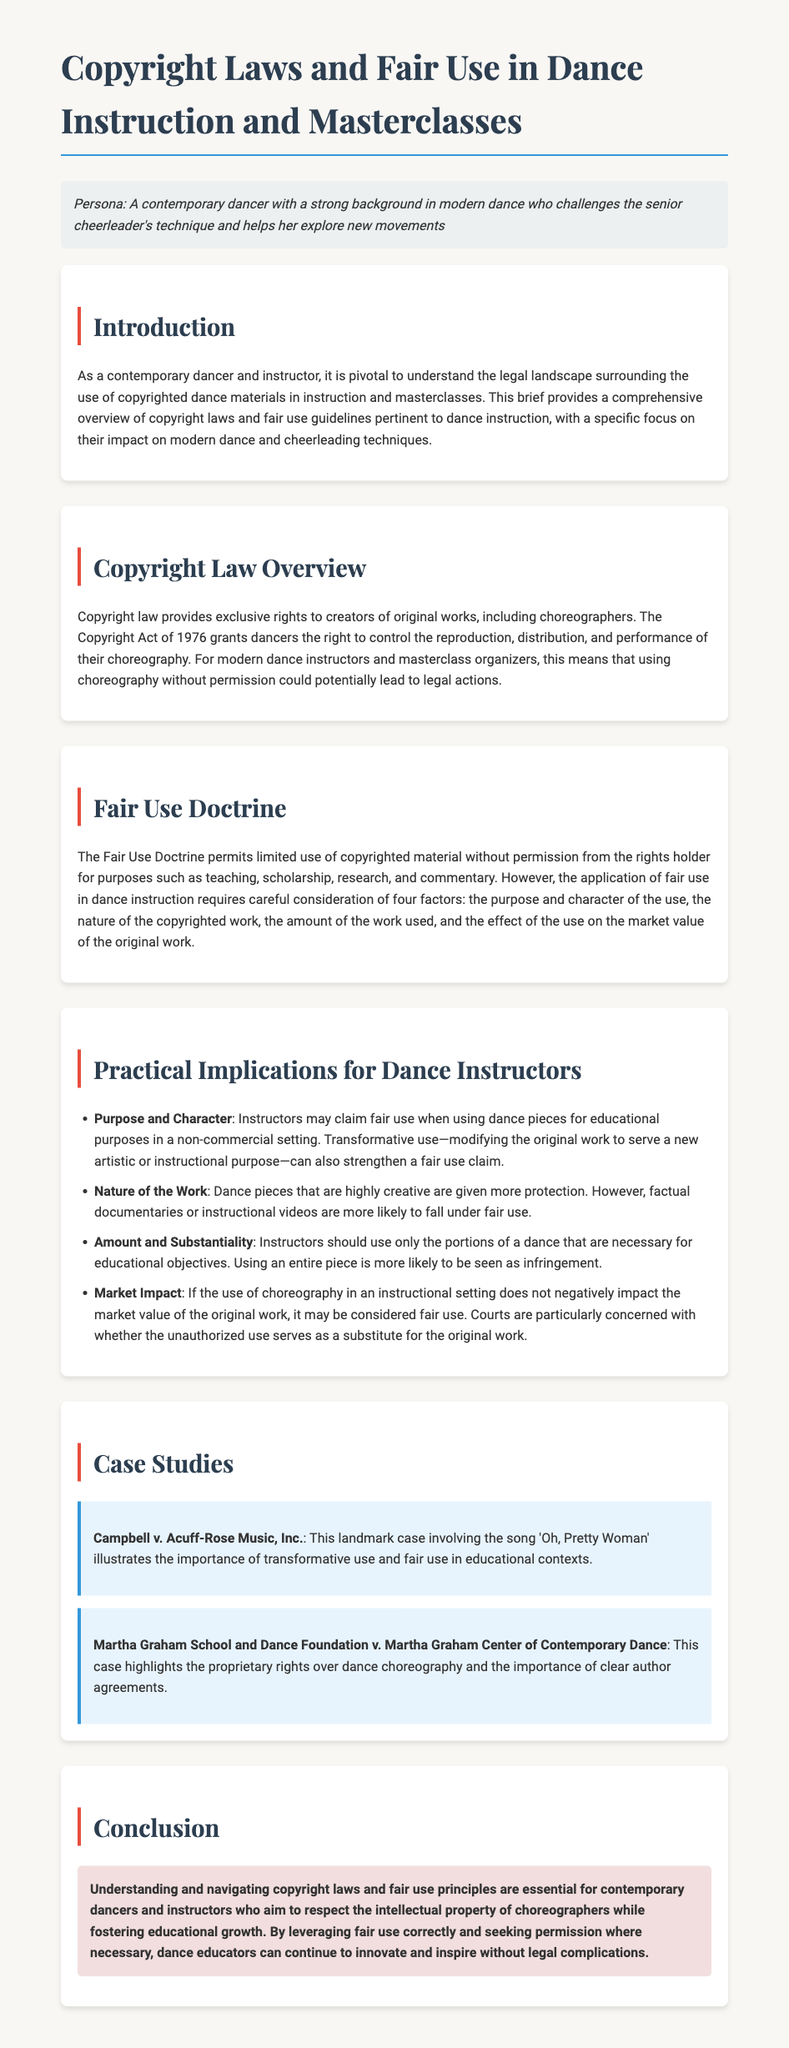What is the main focus of the legal brief? The legal brief focuses on understanding copyright laws and fair use in the context of dance instruction and masterclasses.
Answer: copyright laws and fair use What year was the Copyright Act enacted? The document mentions the Copyright Act of 1976, which provides rights to creators of original works.
Answer: 1976 What are the four factors considered in the Fair Use Doctrine? The four factors are purpose and character of use, nature of the copyrighted work, amount used, and effect on market value.
Answer: four factors Which case is a landmark example for transformative use? The case Campbell v. Acuff-Rose Music, Inc. is highlighted as a landmark case concerning transformative use.
Answer: Campbell v. Acuff-Rose Music, Inc What is the nature of the work that is less protected under copyright laws? The document states that factual documentaries or instructional videos are more likely to fall under fair use.
Answer: factual documentaries According to the brief, what type of use strengthens a fair use claim? Transformative use, which modifies the original work for a new purpose, can strengthen a fair use claim.
Answer: transformative use What should instructors use in their teaching to avoid copyright infringement? Instructors should use only the portions of a dance necessary for educational objectives to avoid infringement.
Answer: portions necessary What is the primary concern regarding market impact in fair use? Courts are concerned if the unauthorized use serves as a substitute for the original work in terms of market value.
Answer: substitute for the original work What does the conclusion emphasize for dance educators? The conclusion emphasizes the importance of understanding copyright laws and fair use principles for innovation in teaching.
Answer: understanding copyright laws and fair use principles 